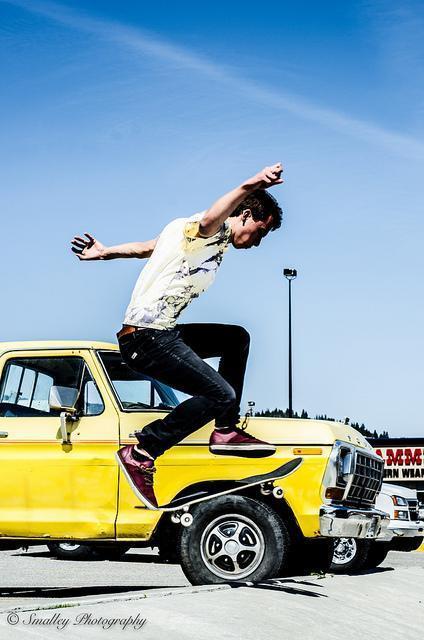How many trucks are there?
Give a very brief answer. 2. 